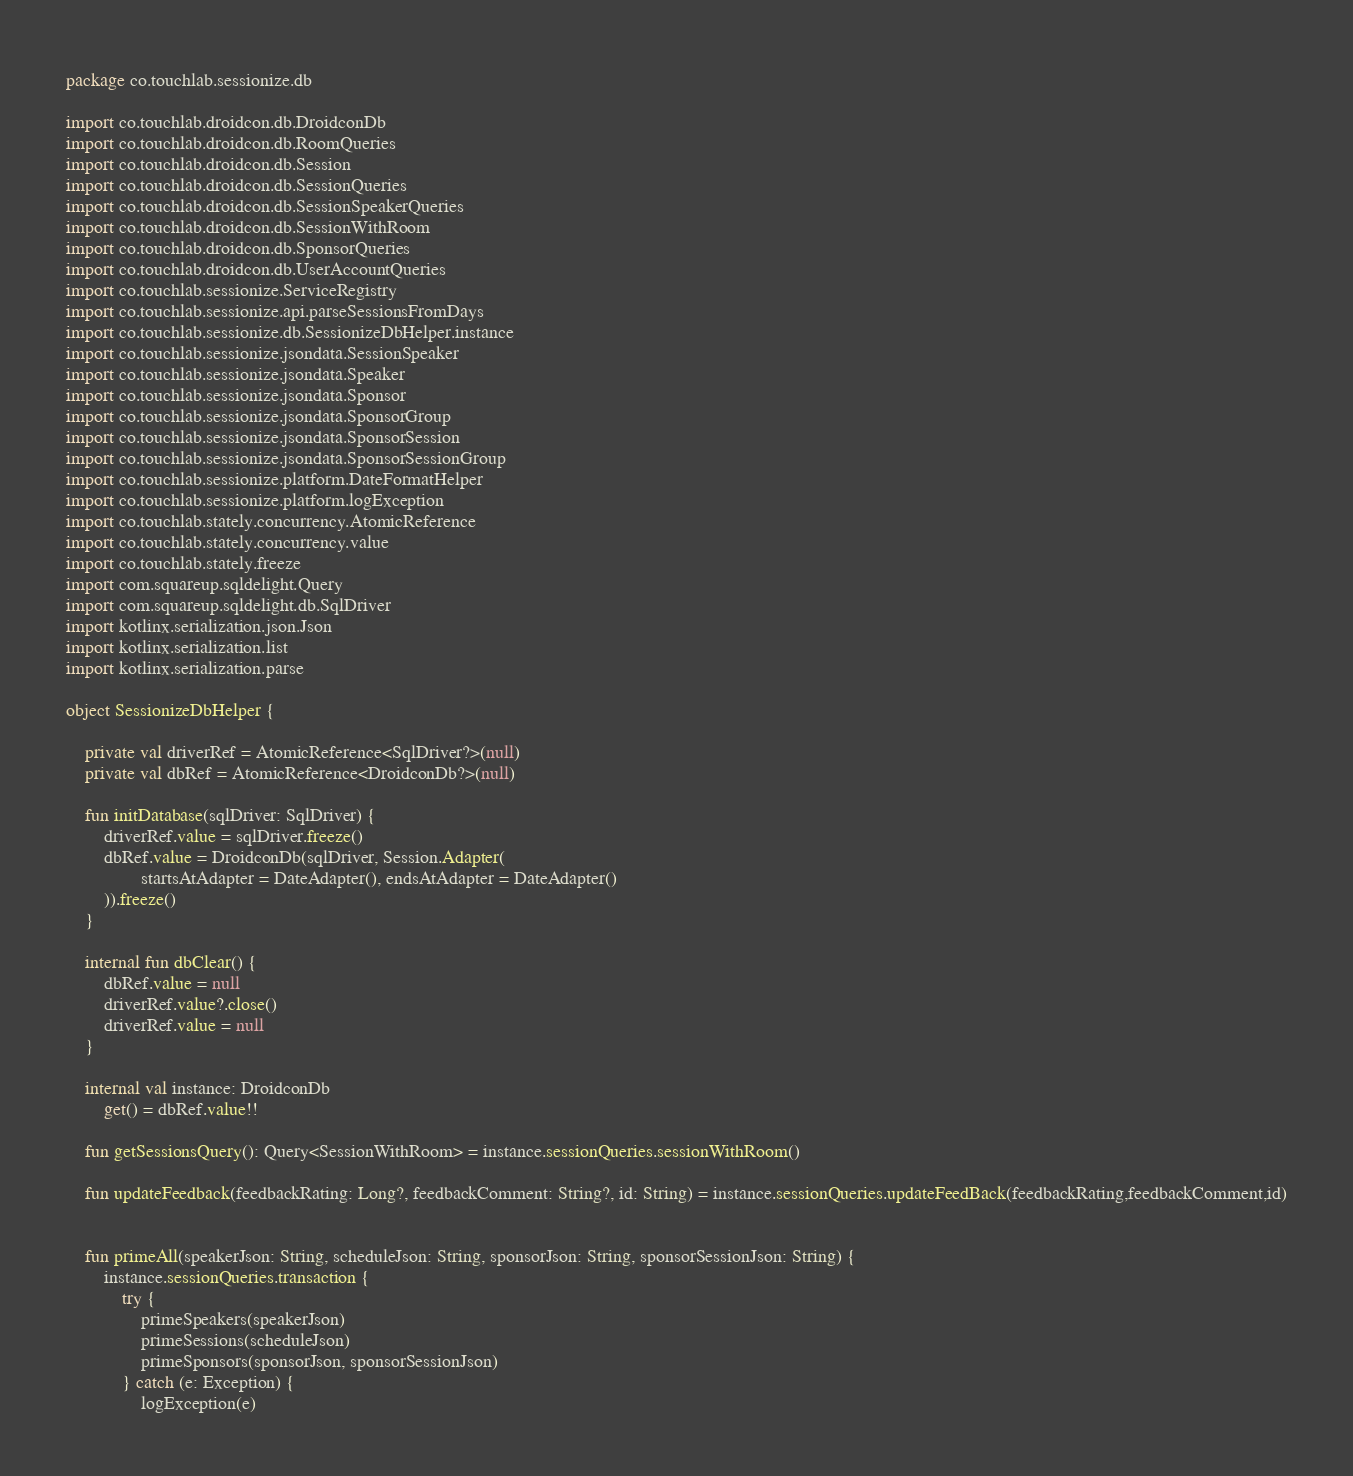<code> <loc_0><loc_0><loc_500><loc_500><_Kotlin_>package co.touchlab.sessionize.db

import co.touchlab.droidcon.db.DroidconDb
import co.touchlab.droidcon.db.RoomQueries
import co.touchlab.droidcon.db.Session
import co.touchlab.droidcon.db.SessionQueries
import co.touchlab.droidcon.db.SessionSpeakerQueries
import co.touchlab.droidcon.db.SessionWithRoom
import co.touchlab.droidcon.db.SponsorQueries
import co.touchlab.droidcon.db.UserAccountQueries
import co.touchlab.sessionize.ServiceRegistry
import co.touchlab.sessionize.api.parseSessionsFromDays
import co.touchlab.sessionize.db.SessionizeDbHelper.instance
import co.touchlab.sessionize.jsondata.SessionSpeaker
import co.touchlab.sessionize.jsondata.Speaker
import co.touchlab.sessionize.jsondata.Sponsor
import co.touchlab.sessionize.jsondata.SponsorGroup
import co.touchlab.sessionize.jsondata.SponsorSession
import co.touchlab.sessionize.jsondata.SponsorSessionGroup
import co.touchlab.sessionize.platform.DateFormatHelper
import co.touchlab.sessionize.platform.logException
import co.touchlab.stately.concurrency.AtomicReference
import co.touchlab.stately.concurrency.value
import co.touchlab.stately.freeze
import com.squareup.sqldelight.Query
import com.squareup.sqldelight.db.SqlDriver
import kotlinx.serialization.json.Json
import kotlinx.serialization.list
import kotlinx.serialization.parse

object SessionizeDbHelper {

    private val driverRef = AtomicReference<SqlDriver?>(null)
    private val dbRef = AtomicReference<DroidconDb?>(null)

    fun initDatabase(sqlDriver: SqlDriver) {
        driverRef.value = sqlDriver.freeze()
        dbRef.value = DroidconDb(sqlDriver, Session.Adapter(
                startsAtAdapter = DateAdapter(), endsAtAdapter = DateAdapter()
        )).freeze()
    }

    internal fun dbClear() {
        dbRef.value = null
        driverRef.value?.close()
        driverRef.value = null
    }

    internal val instance: DroidconDb
        get() = dbRef.value!!

    fun getSessionsQuery(): Query<SessionWithRoom> = instance.sessionQueries.sessionWithRoom()

    fun updateFeedback(feedbackRating: Long?, feedbackComment: String?, id: String) = instance.sessionQueries.updateFeedBack(feedbackRating,feedbackComment,id)


    fun primeAll(speakerJson: String, scheduleJson: String, sponsorJson: String, sponsorSessionJson: String) {
        instance.sessionQueries.transaction {
            try {
                primeSpeakers(speakerJson)
                primeSessions(scheduleJson)
                primeSponsors(sponsorJson, sponsorSessionJson)
            } catch (e: Exception) {
                logException(e)</code> 